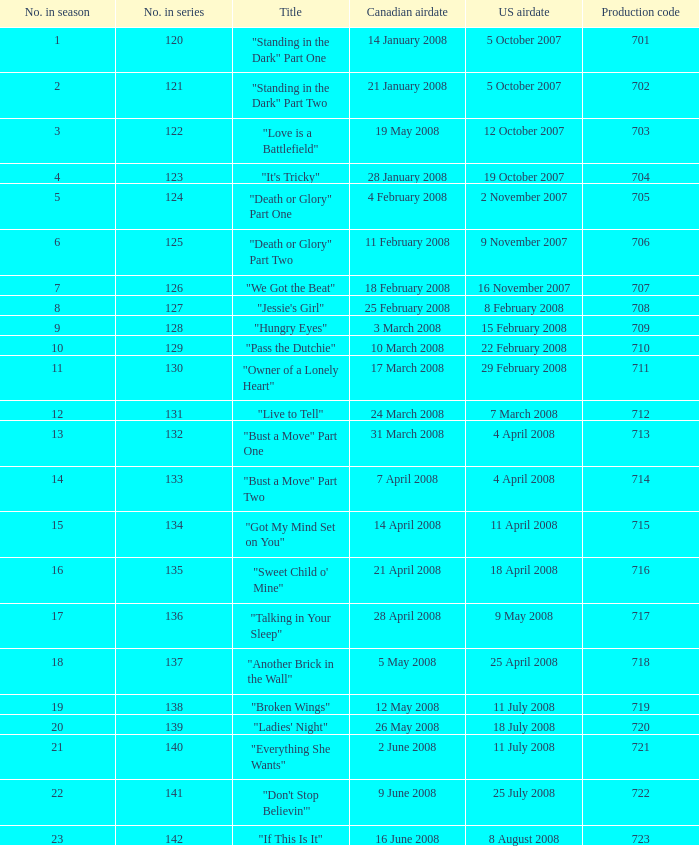The canadian airdate of 17 march 2008 had how many episodes in the season? 1.0. 